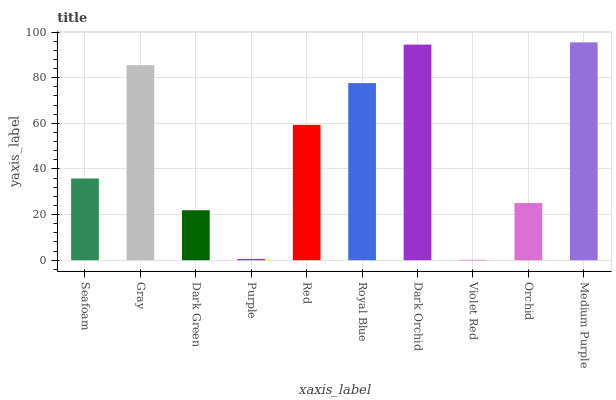Is Gray the minimum?
Answer yes or no. No. Is Gray the maximum?
Answer yes or no. No. Is Gray greater than Seafoam?
Answer yes or no. Yes. Is Seafoam less than Gray?
Answer yes or no. Yes. Is Seafoam greater than Gray?
Answer yes or no. No. Is Gray less than Seafoam?
Answer yes or no. No. Is Red the high median?
Answer yes or no. Yes. Is Seafoam the low median?
Answer yes or no. Yes. Is Purple the high median?
Answer yes or no. No. Is Purple the low median?
Answer yes or no. No. 